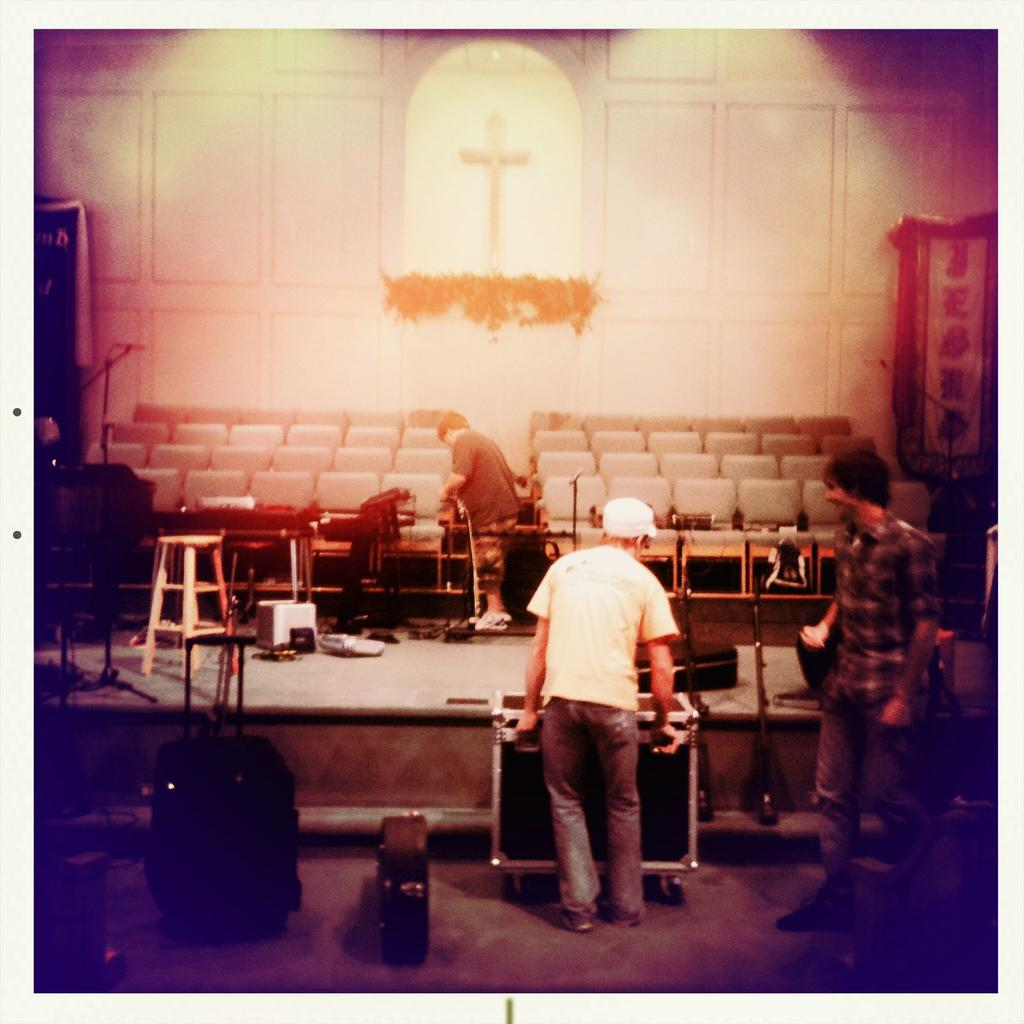Where was the image taken? The image was taken inside a room. What can be seen in the room? There are people standing in the room, and there are chairs as well. Are there any other objects or items in the room? Yes, there are other unspecified items in the room. What can be seen in the background of the room? There is a wall in the background of the room. What is on the wall in the background? There is a cross on the wall. How many tails can be seen on the people in the image? There are no tails visible on the people in the image. What is the size of the committee in the image? There is no committee present in the image. 